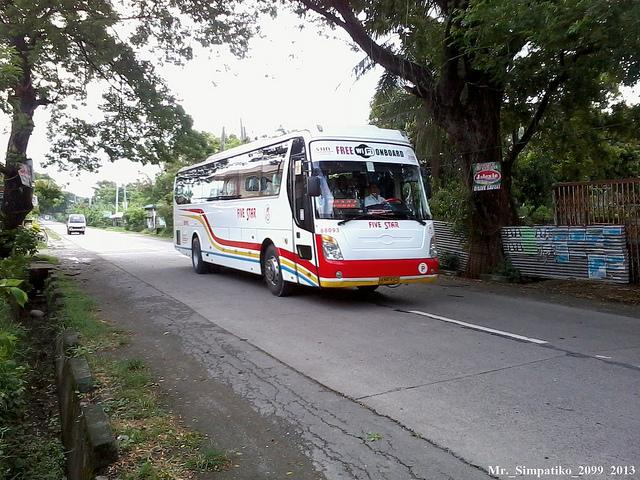What complimentary service does the bus offer on board? Please explain your reasoning. wi-fi. It clearly states on the front of the bus that it offers free wifi. this is a courtesy extended more and more now that internet access is a vital part of so many lives. 